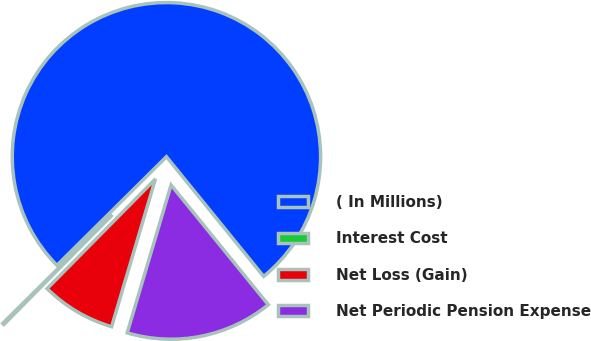Convert chart to OTSL. <chart><loc_0><loc_0><loc_500><loc_500><pie_chart><fcel>( In Millions)<fcel>Interest Cost<fcel>Net Loss (Gain)<fcel>Net Periodic Pension Expense<nl><fcel>76.58%<fcel>0.17%<fcel>7.81%<fcel>15.45%<nl></chart> 